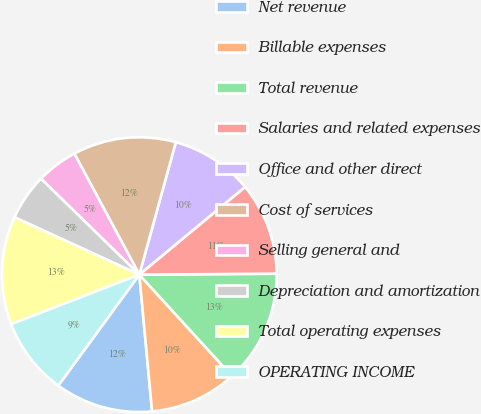Convert chart. <chart><loc_0><loc_0><loc_500><loc_500><pie_chart><fcel>Net revenue<fcel>Billable expenses<fcel>Total revenue<fcel>Salaries and related expenses<fcel>Office and other direct<fcel>Cost of services<fcel>Selling general and<fcel>Depreciation and amortization<fcel>Total operating expenses<fcel>OPERATING INCOME<nl><fcel>11.52%<fcel>10.3%<fcel>13.33%<fcel>10.91%<fcel>9.7%<fcel>12.12%<fcel>4.85%<fcel>5.45%<fcel>12.73%<fcel>9.09%<nl></chart> 